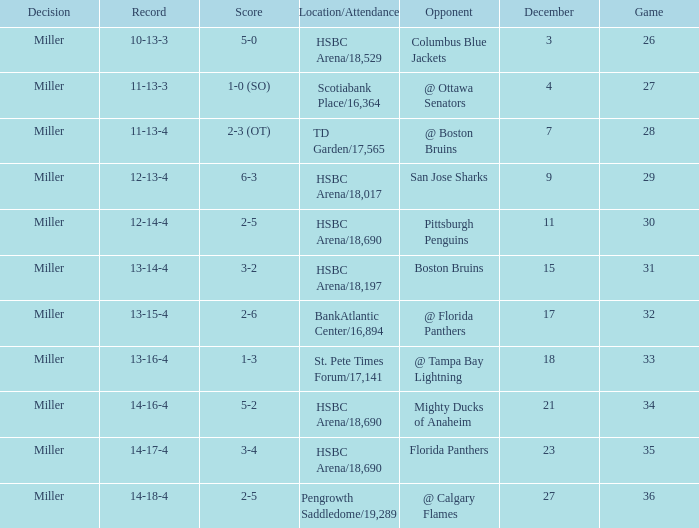Name the december for record 14-17-4 23.0. 